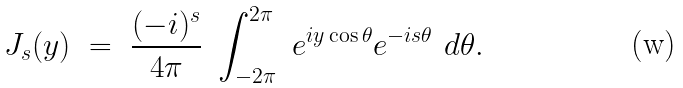<formula> <loc_0><loc_0><loc_500><loc_500>J _ { s } ( y ) \ = \ \frac { ( - i ) ^ { s } } { 4 \pi } \ \int _ { - 2 \pi } ^ { 2 \pi } \ e ^ { i y \cos \theta } e ^ { - i s \theta } \ d \theta .</formula> 